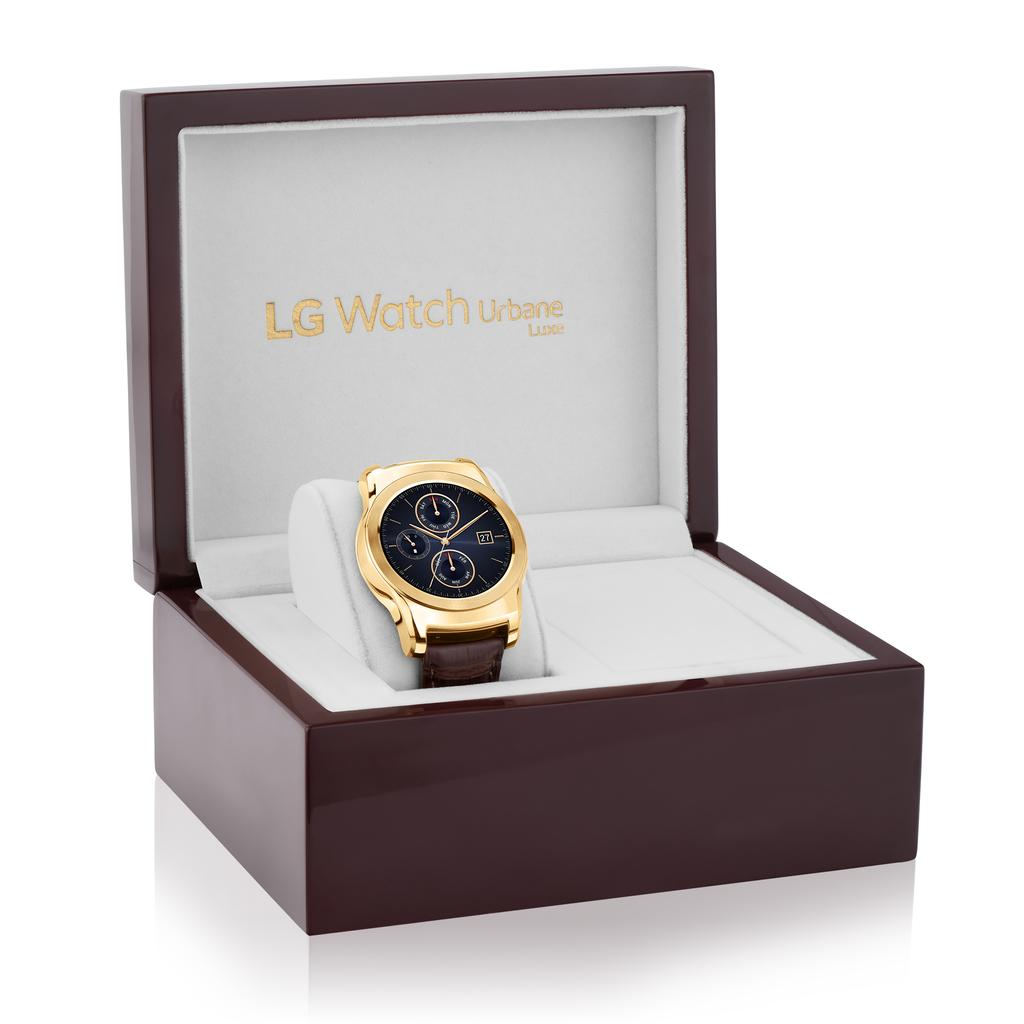<image>
Offer a succinct explanation of the picture presented. Watch inside of a box which says LG Watch on the cover. 